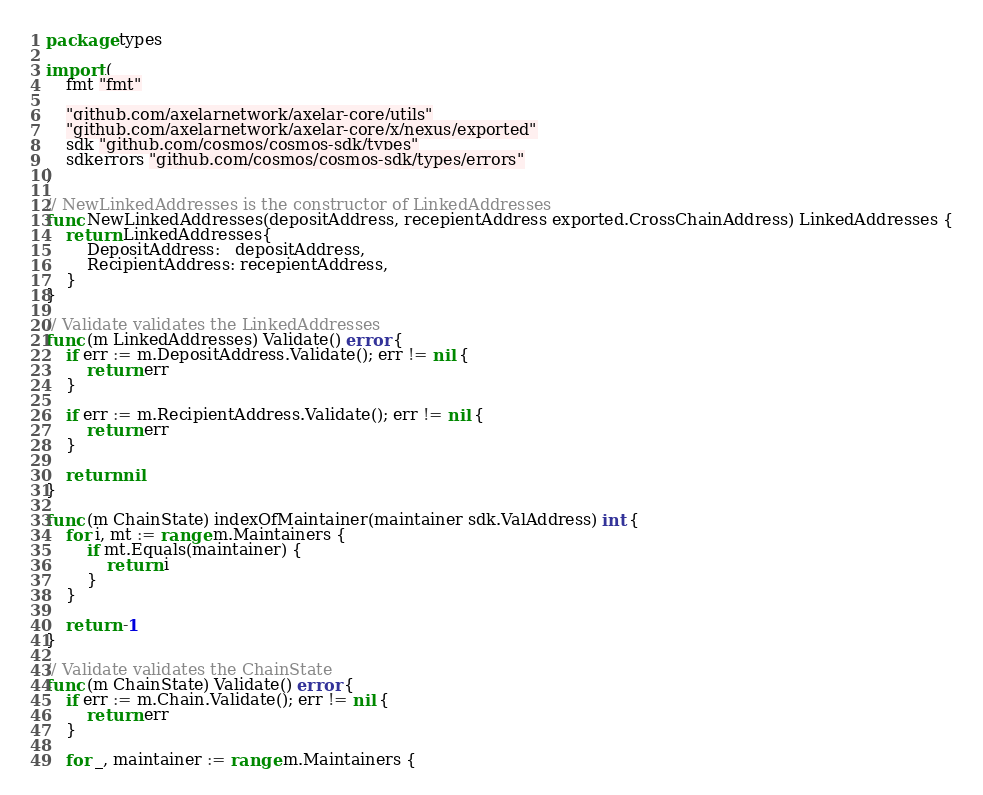Convert code to text. <code><loc_0><loc_0><loc_500><loc_500><_Go_>package types

import (
	fmt "fmt"

	"github.com/axelarnetwork/axelar-core/utils"
	"github.com/axelarnetwork/axelar-core/x/nexus/exported"
	sdk "github.com/cosmos/cosmos-sdk/types"
	sdkerrors "github.com/cosmos/cosmos-sdk/types/errors"
)

// NewLinkedAddresses is the constructor of LinkedAddresses
func NewLinkedAddresses(depositAddress, recepientAddress exported.CrossChainAddress) LinkedAddresses {
	return LinkedAddresses{
		DepositAddress:   depositAddress,
		RecipientAddress: recepientAddress,
	}
}

// Validate validates the LinkedAddresses
func (m LinkedAddresses) Validate() error {
	if err := m.DepositAddress.Validate(); err != nil {
		return err
	}

	if err := m.RecipientAddress.Validate(); err != nil {
		return err
	}

	return nil
}

func (m ChainState) indexOfMaintainer(maintainer sdk.ValAddress) int {
	for i, mt := range m.Maintainers {
		if mt.Equals(maintainer) {
			return i
		}
	}

	return -1
}

// Validate validates the ChainState
func (m ChainState) Validate() error {
	if err := m.Chain.Validate(); err != nil {
		return err
	}

	for _, maintainer := range m.Maintainers {</code> 